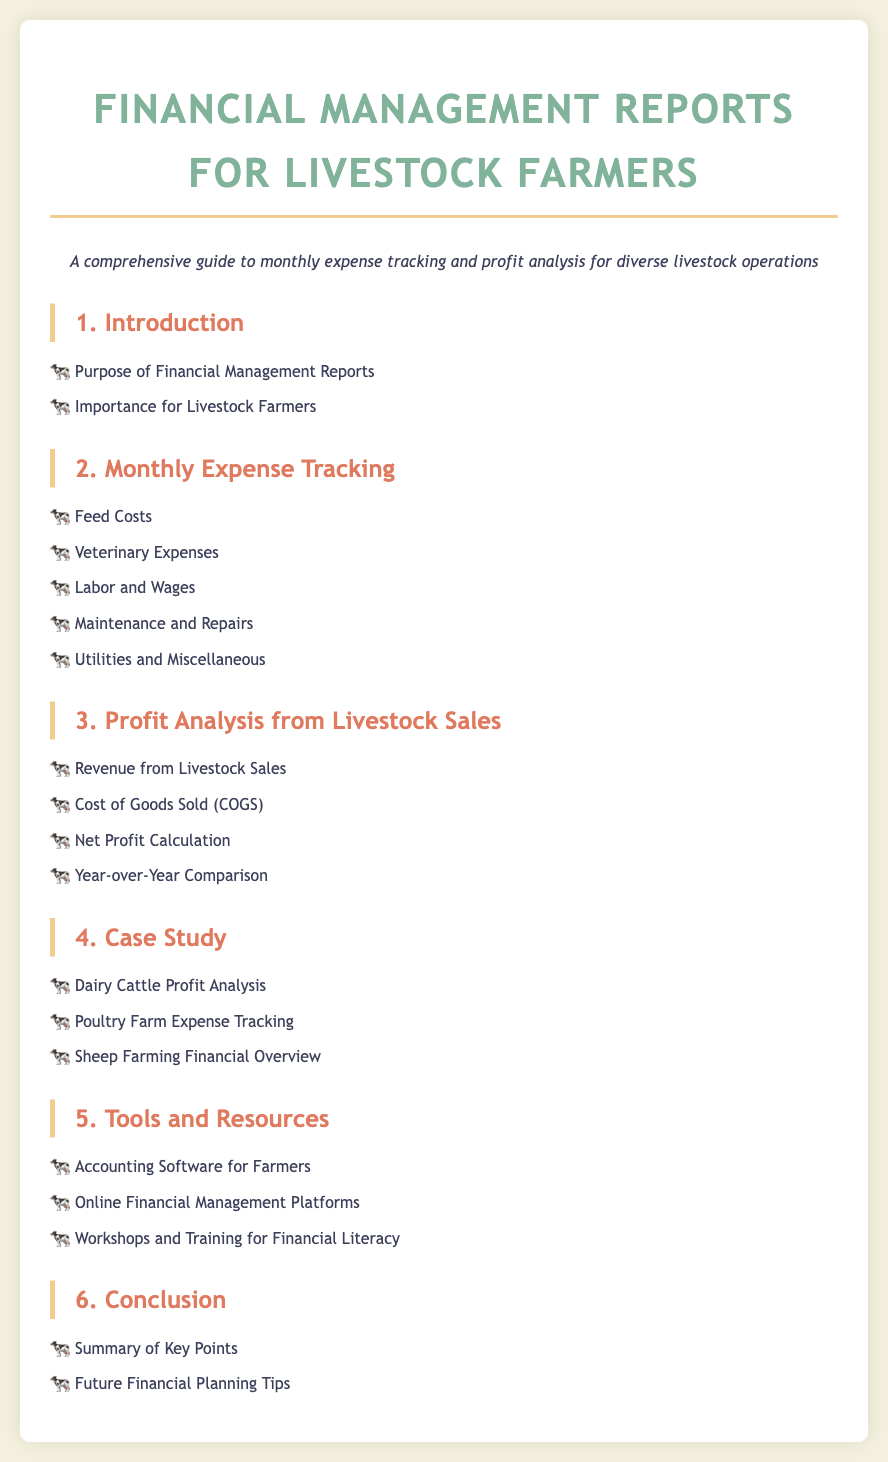What is the purpose of Financial Management Reports? The purpose is to provide a comprehensive guide to monthly expense tracking and profit analysis for livestock operations.
Answer: Comprehensive guide What are the monthly expenses tracked? The document lists specific expenses such as feed costs, veterinary expenses, and labor and wages.
Answer: Feed costs, veterinary expenses, labor and wages What section covers Revenue from Livestock Sales? It is covered under the "Profit Analysis from Livestock Sales" section in the document.
Answer: Profit Analysis from Livestock Sales What type of farm is analyzed in the case study? The case study includes an analysis of dairy cattle profit, poultry farm expense tracking, and sheep farming.
Answer: Dairy cattle, poultry farm, sheep farming What is one tool recommended for farmers? The document suggests using accounting software specifically designed for farmers to manage finances.
Answer: Accounting Software for Farmers 